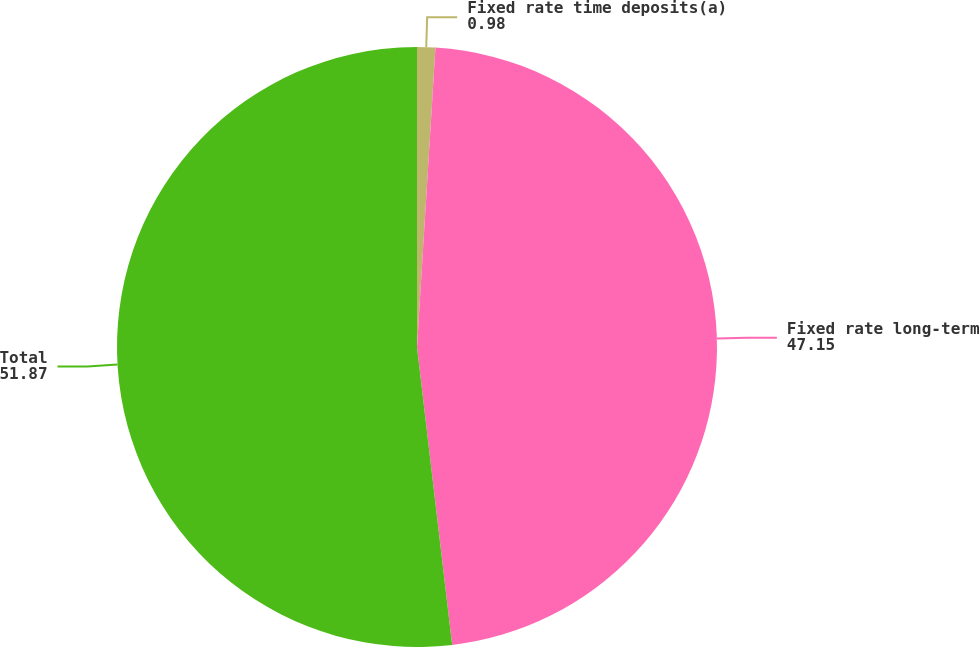Convert chart. <chart><loc_0><loc_0><loc_500><loc_500><pie_chart><fcel>Fixed rate time deposits(a)<fcel>Fixed rate long-term<fcel>Total<nl><fcel>0.98%<fcel>47.15%<fcel>51.87%<nl></chart> 